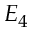Convert formula to latex. <formula><loc_0><loc_0><loc_500><loc_500>E _ { 4 }</formula> 